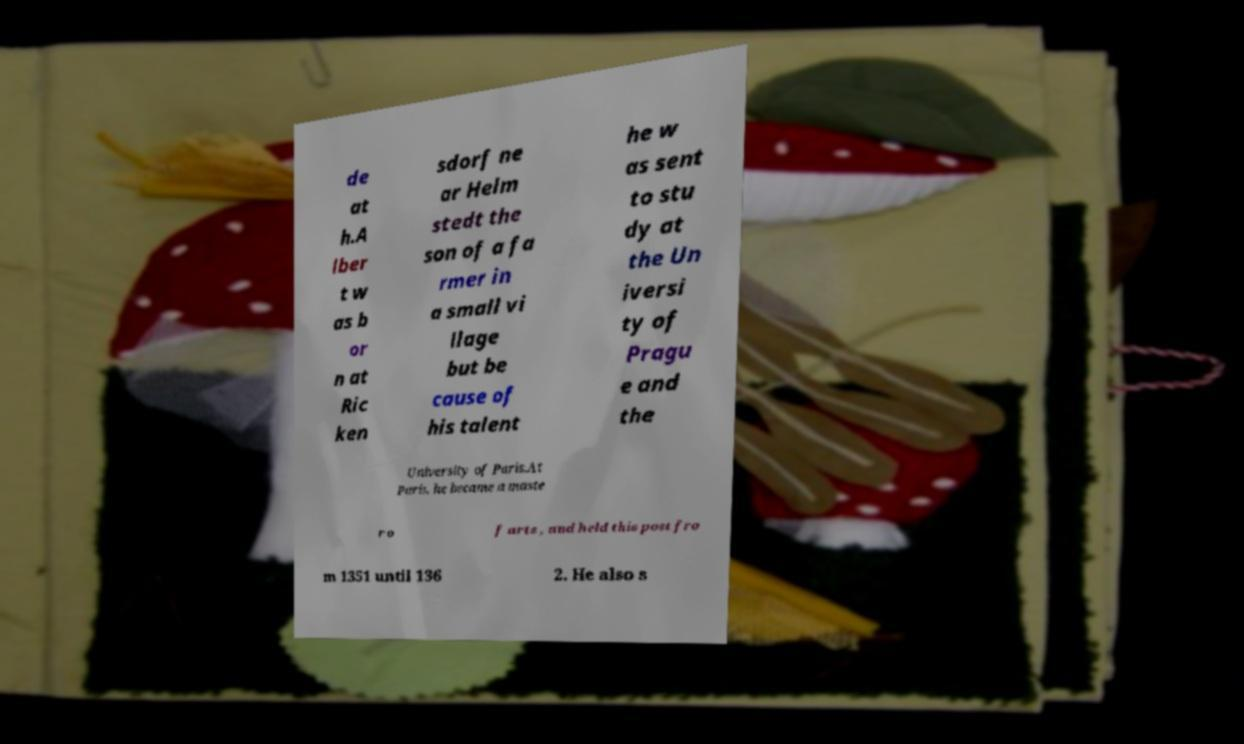What messages or text are displayed in this image? I need them in a readable, typed format. de at h.A lber t w as b or n at Ric ken sdorf ne ar Helm stedt the son of a fa rmer in a small vi llage but be cause of his talent he w as sent to stu dy at the Un iversi ty of Pragu e and the University of Paris.At Paris, he became a maste r o f arts , and held this post fro m 1351 until 136 2. He also s 